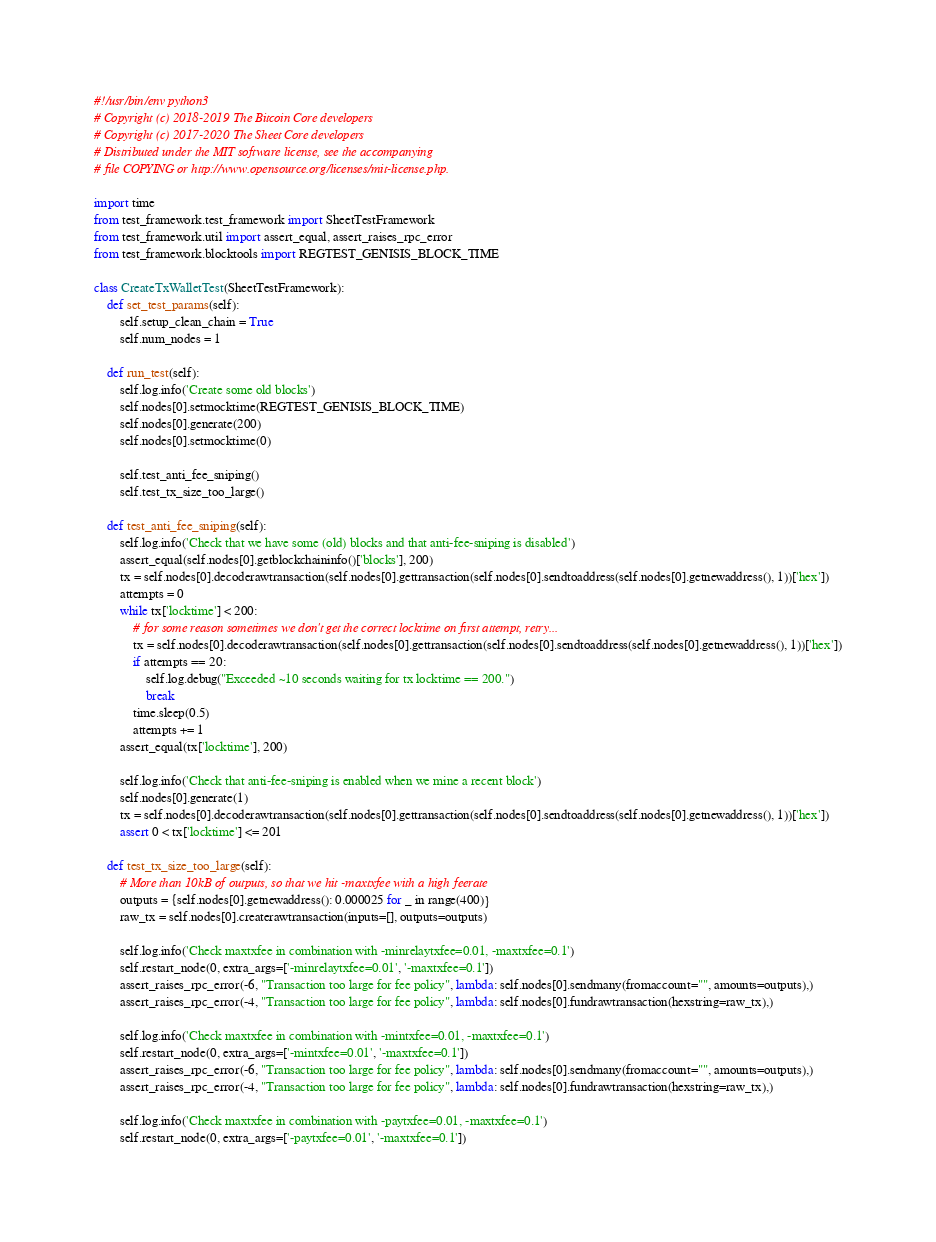<code> <loc_0><loc_0><loc_500><loc_500><_Python_>#!/usr/bin/env python3
# Copyright (c) 2018-2019 The Bitcoin Core developers
# Copyright (c) 2017-2020 The Sheet Core developers
# Distributed under the MIT software license, see the accompanying
# file COPYING or http://www.opensource.org/licenses/mit-license.php.

import time
from test_framework.test_framework import SheetTestFramework
from test_framework.util import assert_equal, assert_raises_rpc_error
from test_framework.blocktools import REGTEST_GENISIS_BLOCK_TIME

class CreateTxWalletTest(SheetTestFramework):
    def set_test_params(self):
        self.setup_clean_chain = True
        self.num_nodes = 1

    def run_test(self):
        self.log.info('Create some old blocks')
        self.nodes[0].setmocktime(REGTEST_GENISIS_BLOCK_TIME)
        self.nodes[0].generate(200)
        self.nodes[0].setmocktime(0)

        self.test_anti_fee_sniping()
        self.test_tx_size_too_large()

    def test_anti_fee_sniping(self):
        self.log.info('Check that we have some (old) blocks and that anti-fee-sniping is disabled')
        assert_equal(self.nodes[0].getblockchaininfo()['blocks'], 200)
        tx = self.nodes[0].decoderawtransaction(self.nodes[0].gettransaction(self.nodes[0].sendtoaddress(self.nodes[0].getnewaddress(), 1))['hex'])
        attempts = 0
        while tx['locktime'] < 200:
            # for some reason sometimes we don't get the correct locktime on first attempt, retry...
            tx = self.nodes[0].decoderawtransaction(self.nodes[0].gettransaction(self.nodes[0].sendtoaddress(self.nodes[0].getnewaddress(), 1))['hex'])
            if attempts == 20:
                self.log.debug("Exceeded ~10 seconds waiting for tx locktime == 200.")
                break
            time.sleep(0.5)
            attempts += 1
        assert_equal(tx['locktime'], 200)

        self.log.info('Check that anti-fee-sniping is enabled when we mine a recent block')
        self.nodes[0].generate(1)
        tx = self.nodes[0].decoderawtransaction(self.nodes[0].gettransaction(self.nodes[0].sendtoaddress(self.nodes[0].getnewaddress(), 1))['hex'])
        assert 0 < tx['locktime'] <= 201

    def test_tx_size_too_large(self):
        # More than 10kB of outputs, so that we hit -maxtxfee with a high feerate
        outputs = {self.nodes[0].getnewaddress(): 0.000025 for _ in range(400)}
        raw_tx = self.nodes[0].createrawtransaction(inputs=[], outputs=outputs)

        self.log.info('Check maxtxfee in combination with -minrelaytxfee=0.01, -maxtxfee=0.1')
        self.restart_node(0, extra_args=['-minrelaytxfee=0.01', '-maxtxfee=0.1'])
        assert_raises_rpc_error(-6, "Transaction too large for fee policy", lambda: self.nodes[0].sendmany(fromaccount="", amounts=outputs),)
        assert_raises_rpc_error(-4, "Transaction too large for fee policy", lambda: self.nodes[0].fundrawtransaction(hexstring=raw_tx),)

        self.log.info('Check maxtxfee in combination with -mintxfee=0.01, -maxtxfee=0.1')
        self.restart_node(0, extra_args=['-mintxfee=0.01', '-maxtxfee=0.1'])
        assert_raises_rpc_error(-6, "Transaction too large for fee policy", lambda: self.nodes[0].sendmany(fromaccount="", amounts=outputs),)
        assert_raises_rpc_error(-4, "Transaction too large for fee policy", lambda: self.nodes[0].fundrawtransaction(hexstring=raw_tx),)

        self.log.info('Check maxtxfee in combination with -paytxfee=0.01, -maxtxfee=0.1')
        self.restart_node(0, extra_args=['-paytxfee=0.01', '-maxtxfee=0.1'])</code> 